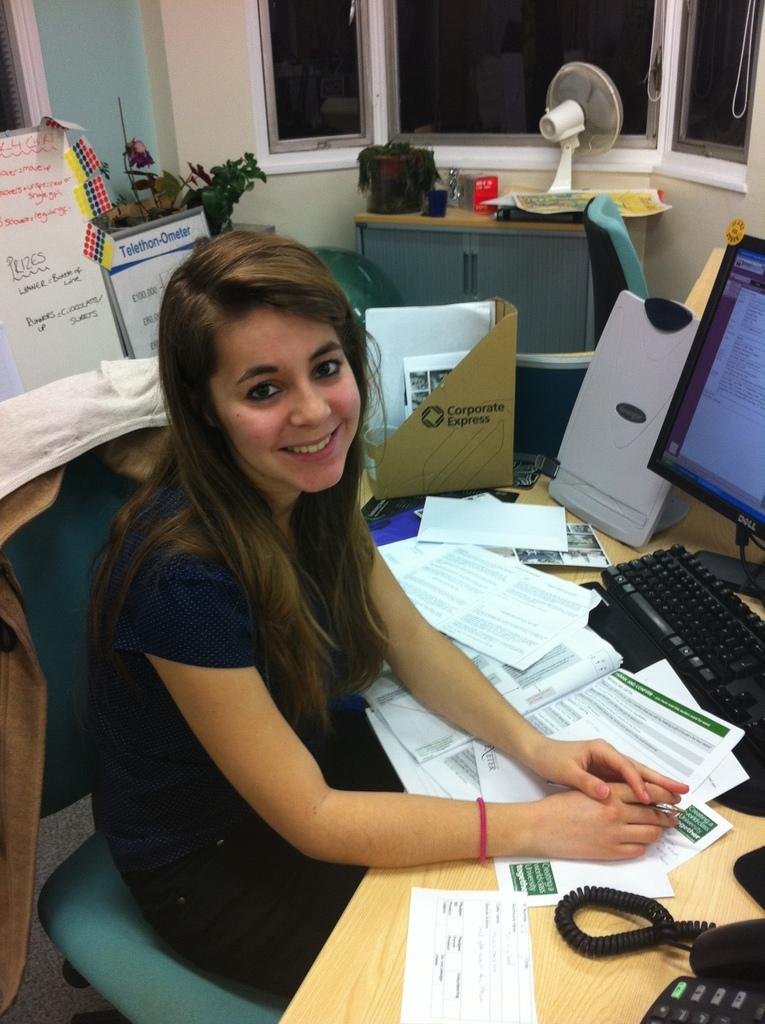Provide a one-sentence caption for the provided image. A woman at a messy desk with a box that says Corporate Express behind her. 